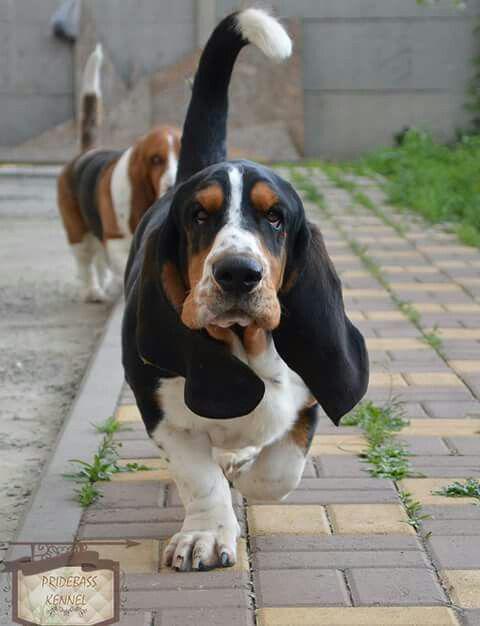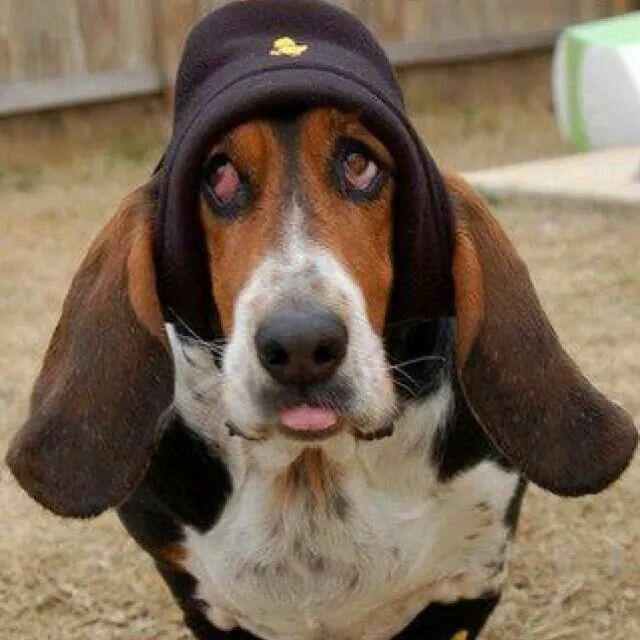The first image is the image on the left, the second image is the image on the right. Given the left and right images, does the statement "There are at most two dogs." hold true? Answer yes or no. No. 